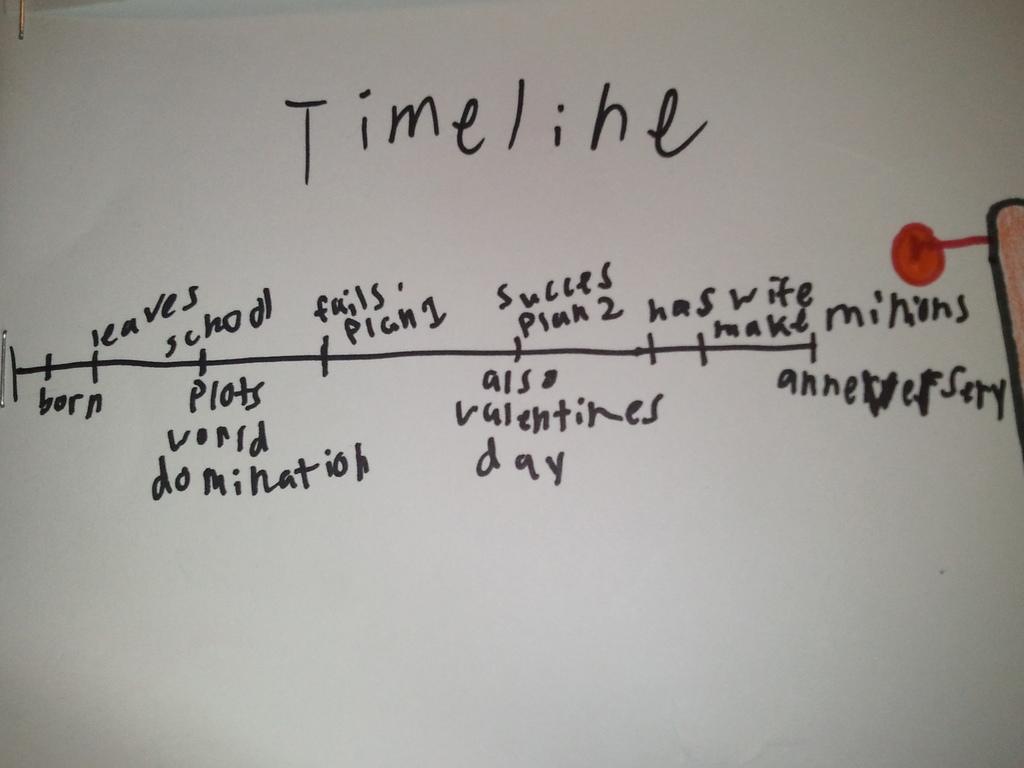What is the first event on this timeline?
Give a very brief answer. Born. What does the title say?
Provide a succinct answer. Timeline. 